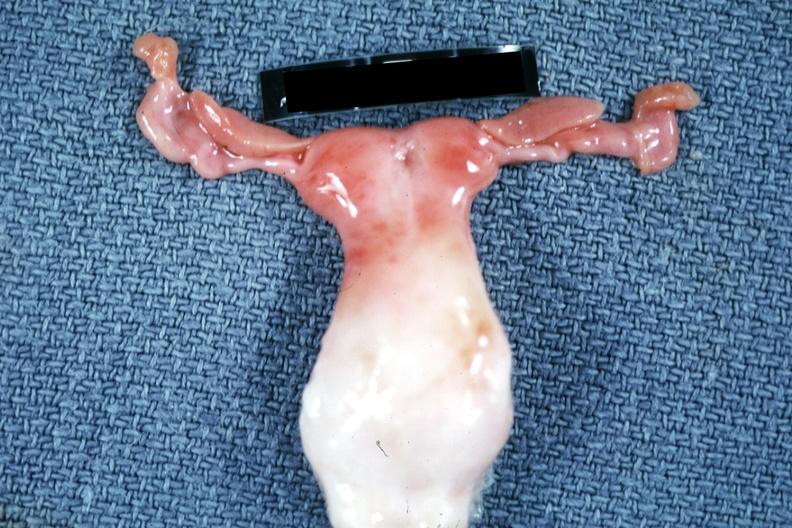what is present?
Answer the question using a single word or phrase. Bicornate uterus 